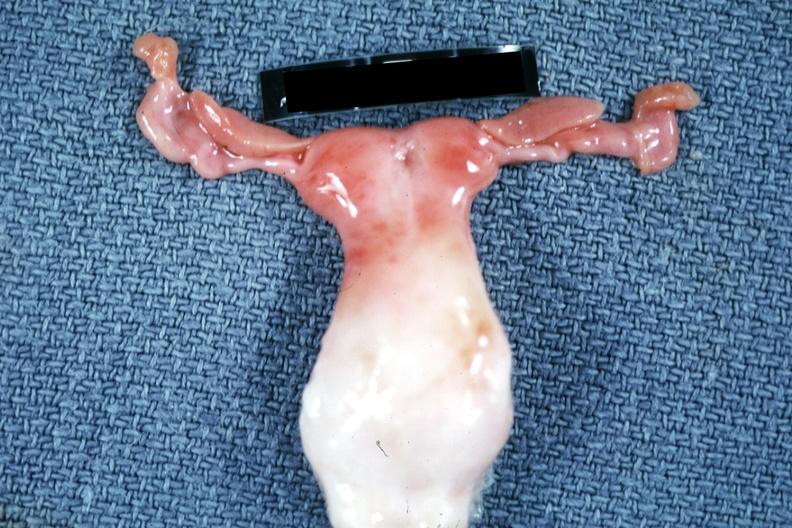what is present?
Answer the question using a single word or phrase. Bicornate uterus 